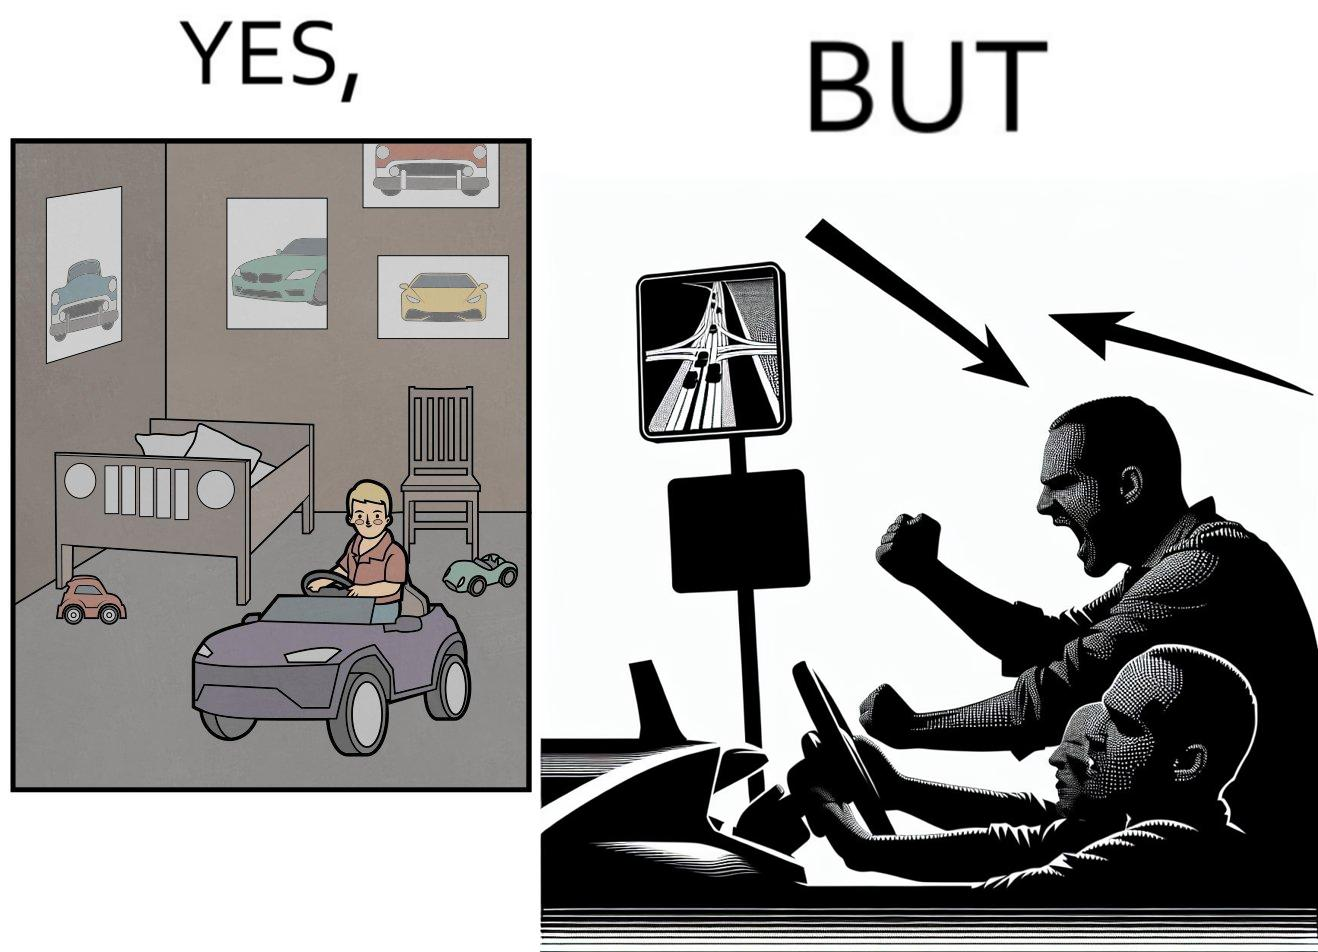Would you classify this image as satirical? Yes, this image is satirical. 